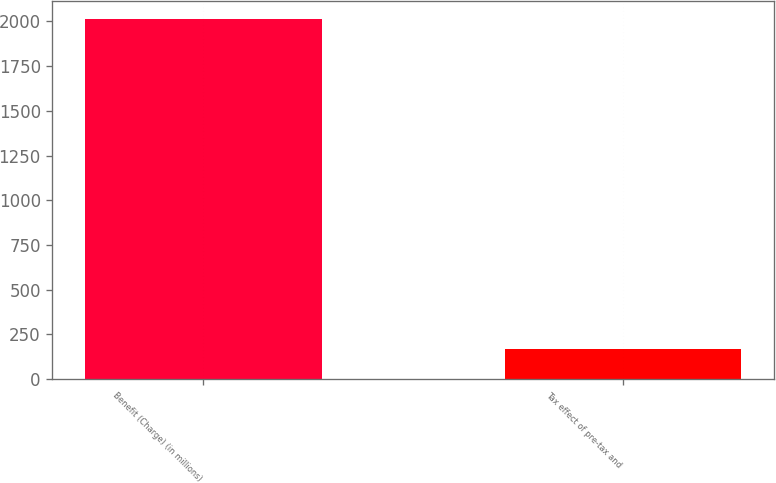<chart> <loc_0><loc_0><loc_500><loc_500><bar_chart><fcel>Benefit (Charge) (in millions)<fcel>Tax effect of pre-tax and<nl><fcel>2013<fcel>167<nl></chart> 